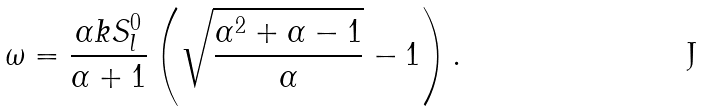<formula> <loc_0><loc_0><loc_500><loc_500>\omega = \frac { \alpha k S _ { l } ^ { 0 } } { \alpha + 1 } \left ( \sqrt { \frac { \alpha ^ { 2 } + \alpha - 1 } { \alpha } } - 1 \right ) .</formula> 